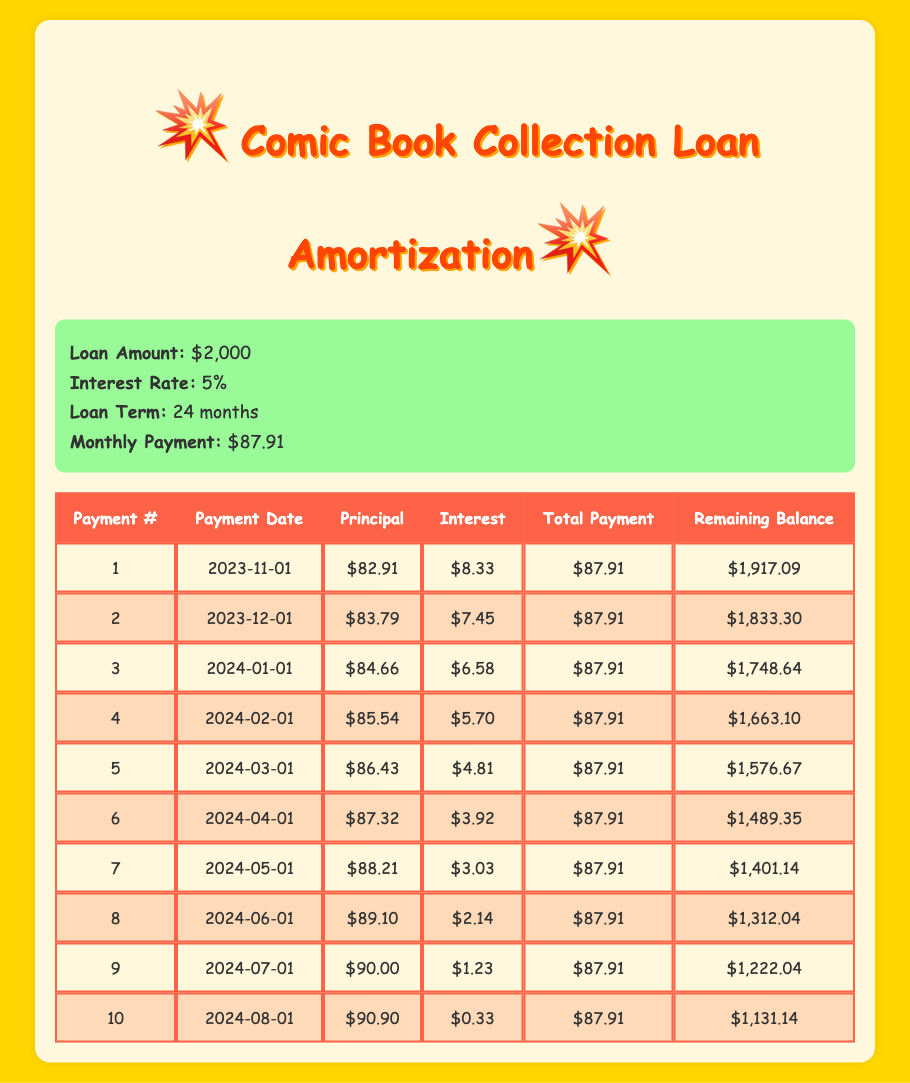What is the monthly payment amount for the comic book collection loan? The monthly payment amount is stated in the loan details section of the table, which is $87.91.
Answer: 87.91 What was the remaining balance after the first payment? After the first payment, the remaining balance is given in the first row of the payment schedule, which shows $1,917.09.
Answer: 1,917.09 What was the total amount of principal paid after the second payment? To find the total principal paid after the second payment, we add the principal amounts from the first two payments: $82.91 (first payment) + $83.79 (second payment) = $166.70.
Answer: 166.70 How much interest was paid in the third payment? The interest paid in the third payment can be found directly in the row for the third payment, which is $6.58.
Answer: 6.58 Is the interest paid on the fourth payment more than $6? The interest for the fourth payment is $5.70, which is less than $6. Therefore, the answer is no.
Answer: No What is the total amount of principal paid after the first four payments? The total principal paid after the first four payments can be calculated by adding the principal amounts of the first four payments: $82.91 + $83.79 + $84.66 + $85.54 = $336.90.
Answer: 336.90 What is the remaining balance after the fifth payment? The remaining balance after the fifth payment is noted in the fifth row of the payment schedule, which is $1,576.67.
Answer: 1,576.67 How does the interest payment change from the second to the third payment? The interest in the second payment is $7.45 and in the third payment it is $6.58. The change is $7.45 - $6.58 = $0.87, indicating a decrease in interest paid by $0.87.
Answer: Decrease of 0.87 Does the table show that the total payments remain constant over time? Yes, the total payment amount for each payment is consistently $87.91 throughout the schedule.
Answer: Yes 